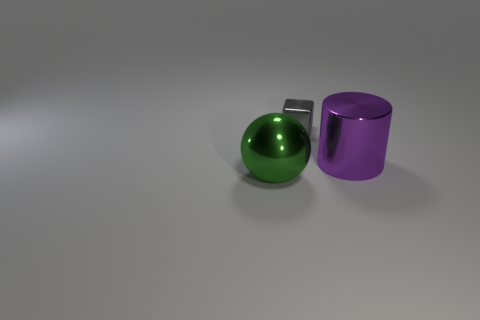Add 2 big metal cylinders. How many objects exist? 5 Subtract all spheres. How many objects are left? 2 Add 1 big yellow metal cubes. How many big yellow metal cubes exist? 1 Subtract 0 blue cylinders. How many objects are left? 3 Subtract all green blocks. Subtract all large metal cylinders. How many objects are left? 2 Add 1 small gray things. How many small gray things are left? 2 